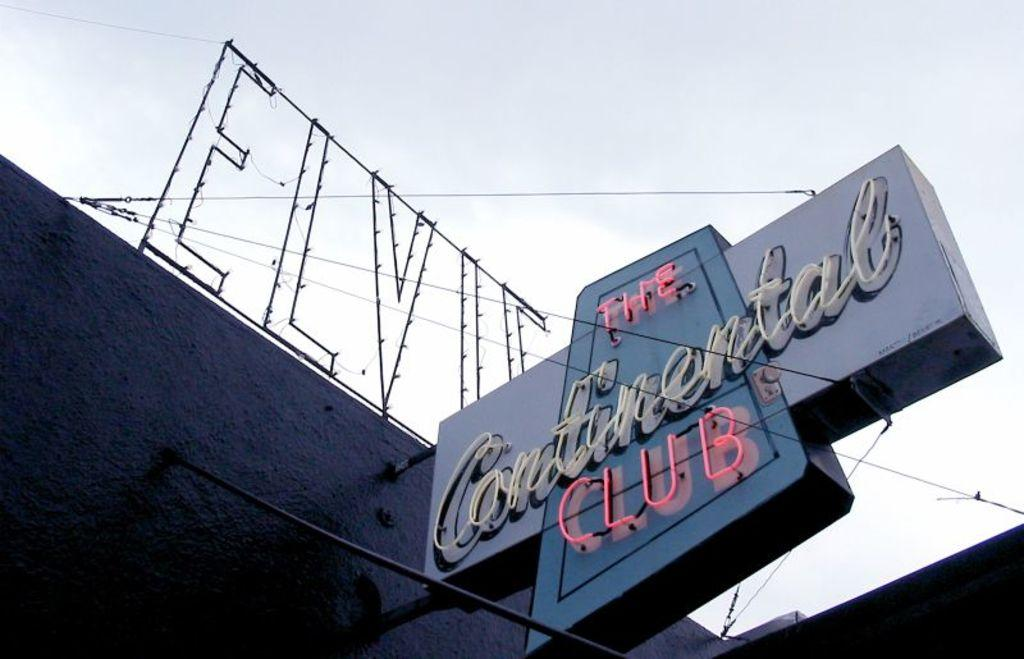<image>
Relay a brief, clear account of the picture shown. LED lights of a club named "The Continental Club". 